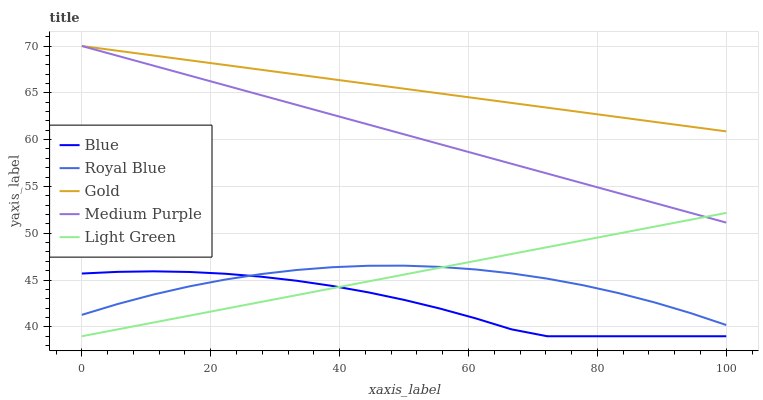Does Blue have the minimum area under the curve?
Answer yes or no. Yes. Does Gold have the maximum area under the curve?
Answer yes or no. Yes. Does Royal Blue have the minimum area under the curve?
Answer yes or no. No. Does Royal Blue have the maximum area under the curve?
Answer yes or no. No. Is Light Green the smoothest?
Answer yes or no. Yes. Is Blue the roughest?
Answer yes or no. Yes. Is Royal Blue the smoothest?
Answer yes or no. No. Is Royal Blue the roughest?
Answer yes or no. No. Does Blue have the lowest value?
Answer yes or no. Yes. Does Royal Blue have the lowest value?
Answer yes or no. No. Does Gold have the highest value?
Answer yes or no. Yes. Does Royal Blue have the highest value?
Answer yes or no. No. Is Blue less than Gold?
Answer yes or no. Yes. Is Gold greater than Blue?
Answer yes or no. Yes. Does Royal Blue intersect Blue?
Answer yes or no. Yes. Is Royal Blue less than Blue?
Answer yes or no. No. Is Royal Blue greater than Blue?
Answer yes or no. No. Does Blue intersect Gold?
Answer yes or no. No. 